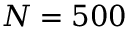Convert formula to latex. <formula><loc_0><loc_0><loc_500><loc_500>N = 5 0 0</formula> 